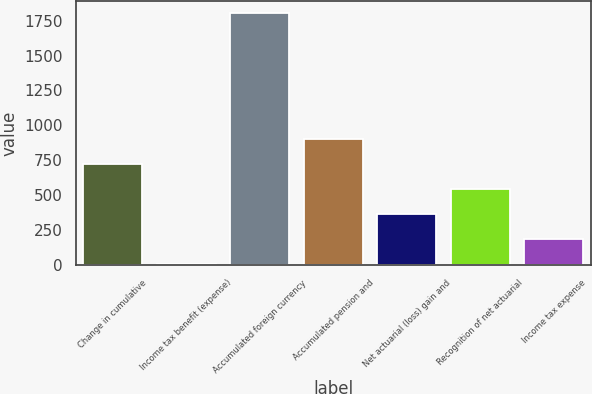Convert chart. <chart><loc_0><loc_0><loc_500><loc_500><bar_chart><fcel>Change in cumulative<fcel>Income tax benefit (expense)<fcel>Accumulated foreign currency<fcel>Accumulated pension and<fcel>Net actuarial (loss) gain and<fcel>Recognition of net actuarial<fcel>Income tax expense<nl><fcel>726.2<fcel>9<fcel>1802<fcel>905.5<fcel>367.6<fcel>546.9<fcel>188.3<nl></chart> 